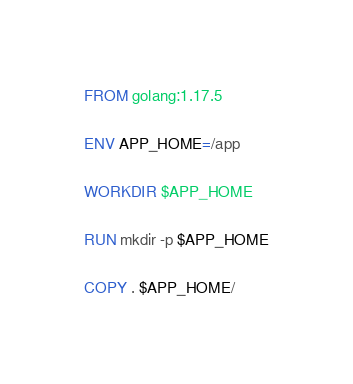Convert code to text. <code><loc_0><loc_0><loc_500><loc_500><_Dockerfile_>FROM golang:1.17.5

ENV APP_HOME=/app

WORKDIR $APP_HOME

RUN mkdir -p $APP_HOME

COPY . $APP_HOME/
</code> 